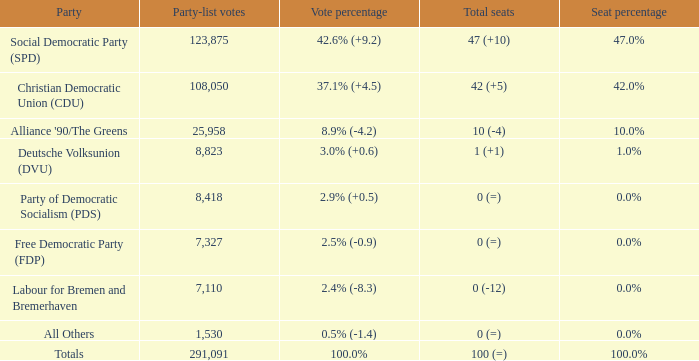4% (- 0.0%. 